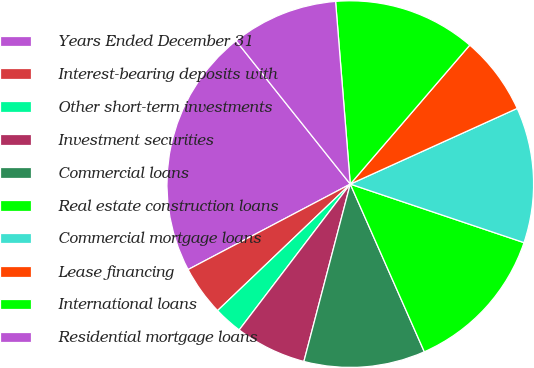<chart> <loc_0><loc_0><loc_500><loc_500><pie_chart><fcel>Years Ended December 31<fcel>Interest-bearing deposits with<fcel>Other short-term investments<fcel>Investment securities<fcel>Commercial loans<fcel>Real estate construction loans<fcel>Commercial mortgage loans<fcel>Lease financing<fcel>International loans<fcel>Residential mortgage loans<nl><fcel>22.01%<fcel>4.4%<fcel>2.52%<fcel>6.29%<fcel>10.69%<fcel>13.21%<fcel>11.95%<fcel>6.92%<fcel>12.58%<fcel>9.43%<nl></chart> 